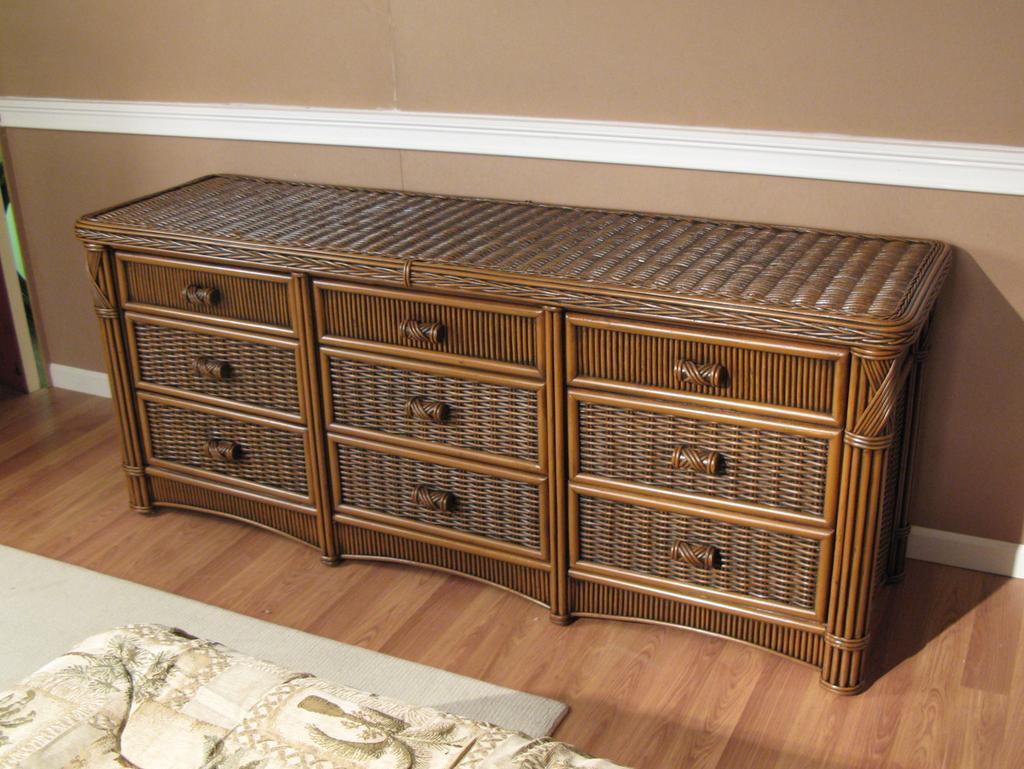Describe this image in one or two sentences. In this picture I can see the mattress in front on which there is a cloth which is of white and cream in color and in the middle of this image I see the drawers and behind it I see the wall and I see the floor. 